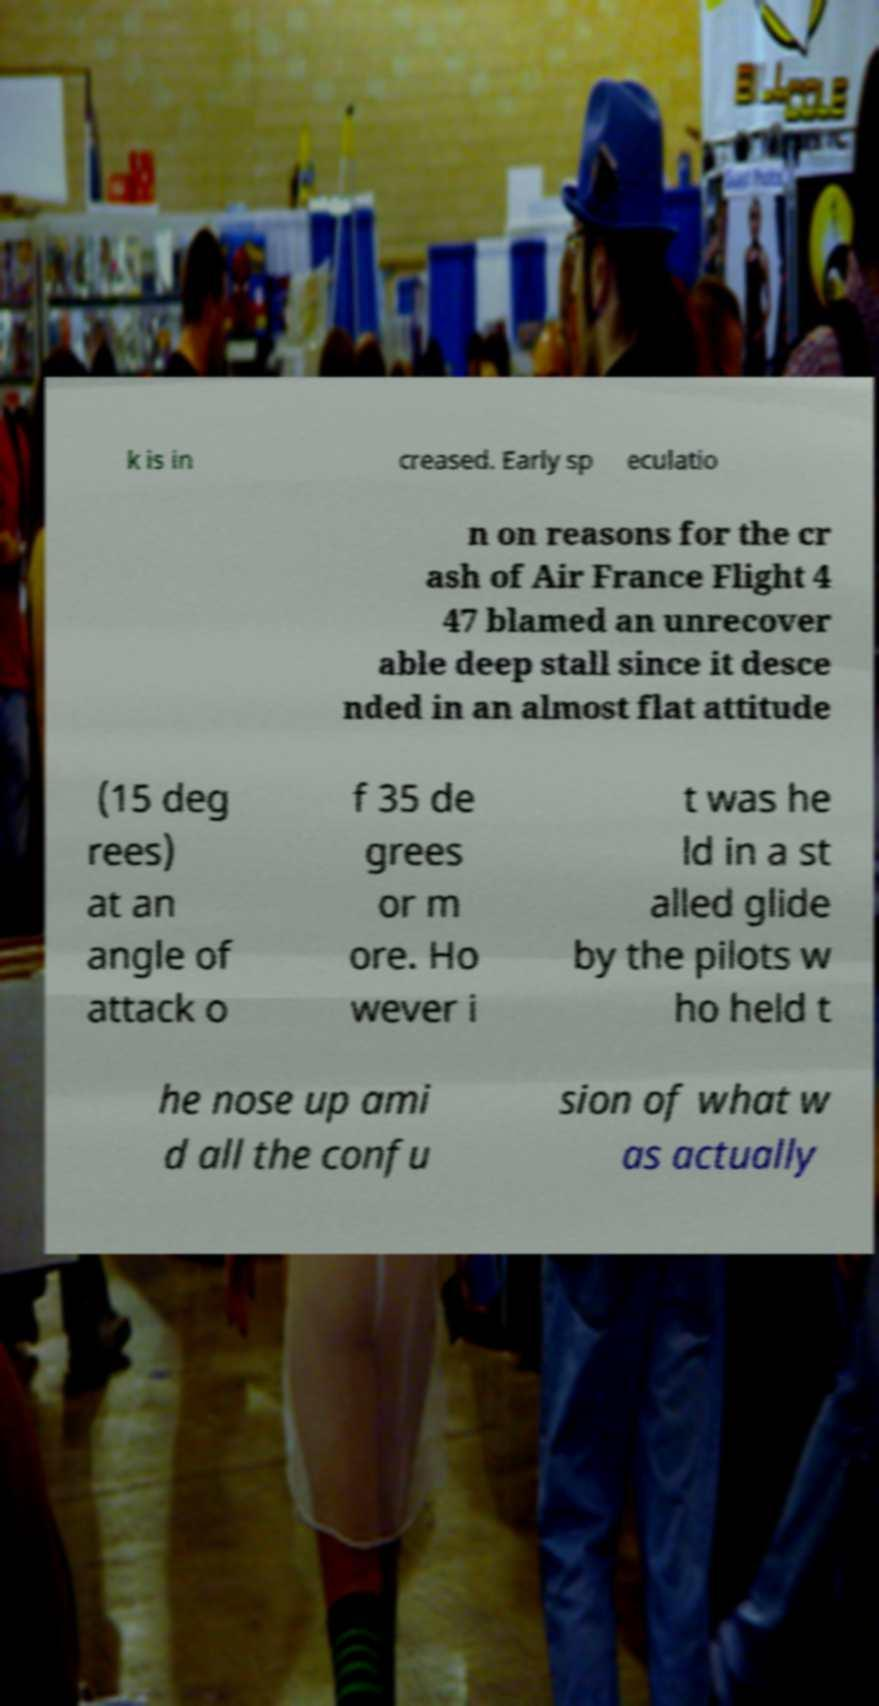For documentation purposes, I need the text within this image transcribed. Could you provide that? k is in creased. Early sp eculatio n on reasons for the cr ash of Air France Flight 4 47 blamed an unrecover able deep stall since it desce nded in an almost flat attitude (15 deg rees) at an angle of attack o f 35 de grees or m ore. Ho wever i t was he ld in a st alled glide by the pilots w ho held t he nose up ami d all the confu sion of what w as actually 